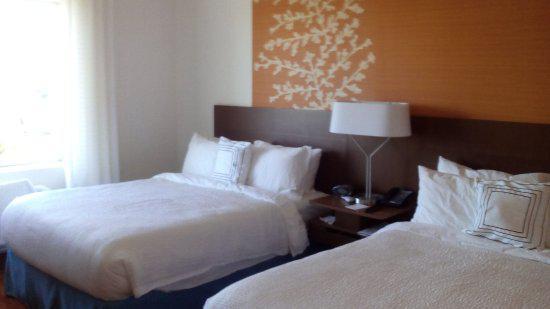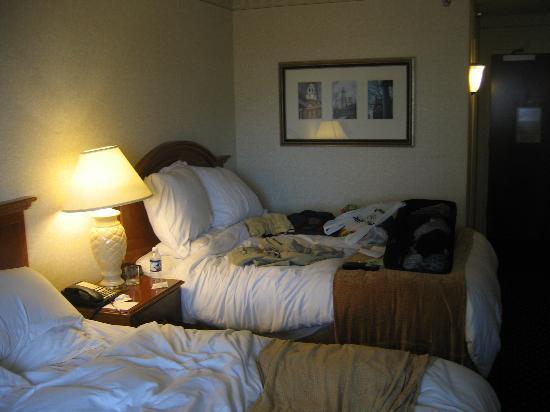The first image is the image on the left, the second image is the image on the right. Evaluate the accuracy of this statement regarding the images: "there are two beds in a room with a picture of a woman on the wall and a blue table between them". Is it true? Answer yes or no. No. The first image is the image on the left, the second image is the image on the right. Assess this claim about the two images: "One room has twin beds with gray bedding, and the other room contains one larger bed with white pillows.". Correct or not? Answer yes or no. No. 